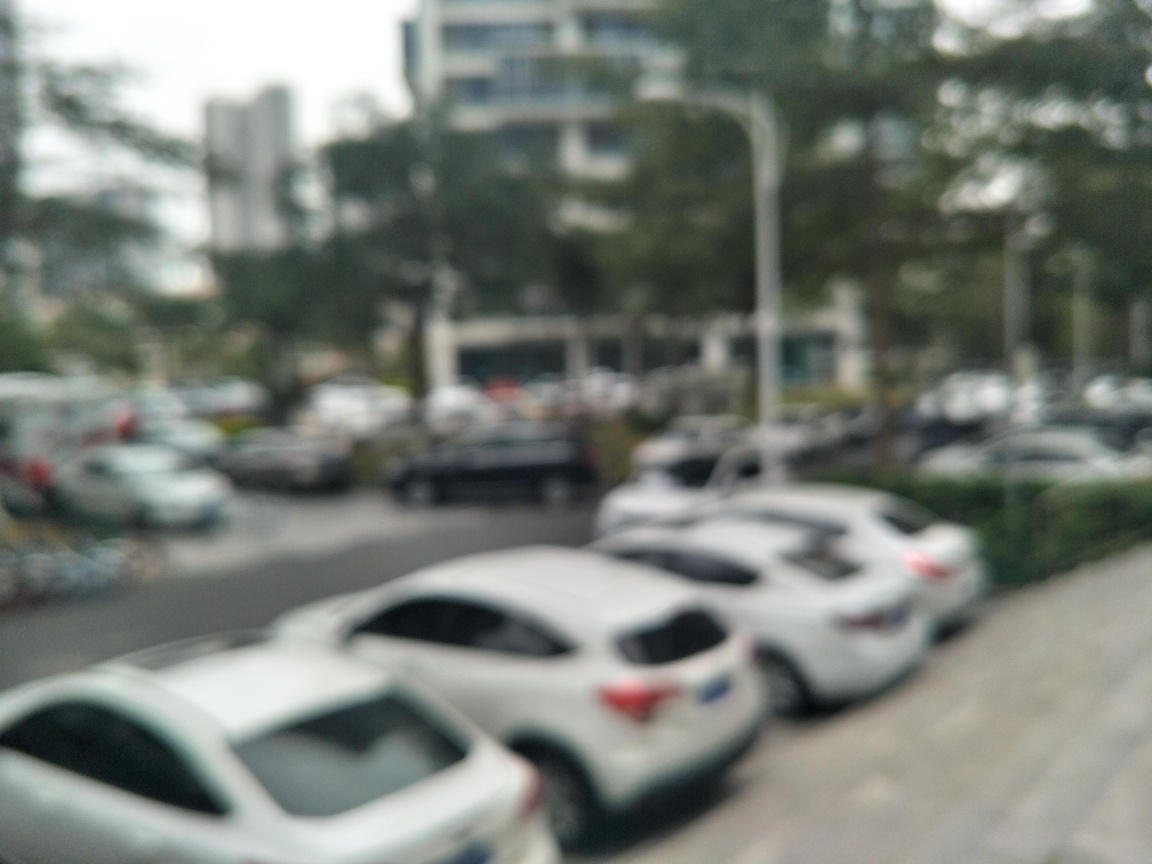Describe the weather or time of day in this image. The lighting in the image is diffuse, suggesting either an overcast day or the diffused light typical of early morning or late afternoon. Unfortunately, the lack of clarity makes it difficult to provide a definitive answer about the weather conditions. 